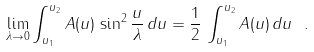<formula> <loc_0><loc_0><loc_500><loc_500>\lim _ { \lambda \rightarrow 0 } \int _ { u _ { 1 } } ^ { u _ { 2 } } A ( u ) \, \sin ^ { 2 } \frac { u } { \lambda } \, d u = \frac { 1 } { 2 } \, \int _ { u _ { 1 } } ^ { u _ { 2 } } A ( u ) \, d u \ .</formula> 